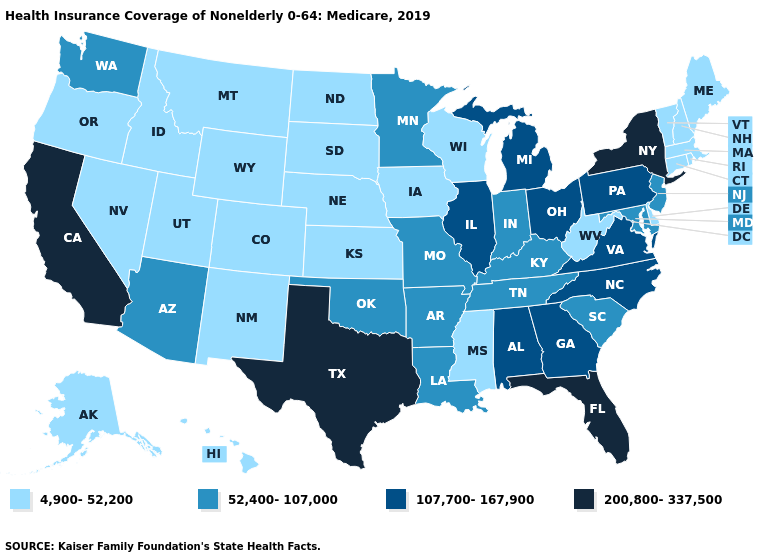Does the first symbol in the legend represent the smallest category?
Be succinct. Yes. What is the value of Hawaii?
Answer briefly. 4,900-52,200. What is the lowest value in states that border Delaware?
Answer briefly. 52,400-107,000. Name the states that have a value in the range 4,900-52,200?
Write a very short answer. Alaska, Colorado, Connecticut, Delaware, Hawaii, Idaho, Iowa, Kansas, Maine, Massachusetts, Mississippi, Montana, Nebraska, Nevada, New Hampshire, New Mexico, North Dakota, Oregon, Rhode Island, South Dakota, Utah, Vermont, West Virginia, Wisconsin, Wyoming. Among the states that border Georgia , does Florida have the highest value?
Give a very brief answer. Yes. What is the lowest value in the USA?
Answer briefly. 4,900-52,200. Name the states that have a value in the range 52,400-107,000?
Write a very short answer. Arizona, Arkansas, Indiana, Kentucky, Louisiana, Maryland, Minnesota, Missouri, New Jersey, Oklahoma, South Carolina, Tennessee, Washington. Name the states that have a value in the range 200,800-337,500?
Be succinct. California, Florida, New York, Texas. Among the states that border Tennessee , does Mississippi have the lowest value?
Give a very brief answer. Yes. Does the map have missing data?
Give a very brief answer. No. Does the map have missing data?
Concise answer only. No. Does California have the highest value in the USA?
Quick response, please. Yes. What is the value of Maine?
Answer briefly. 4,900-52,200. Name the states that have a value in the range 200,800-337,500?
Write a very short answer. California, Florida, New York, Texas. Does the map have missing data?
Write a very short answer. No. 